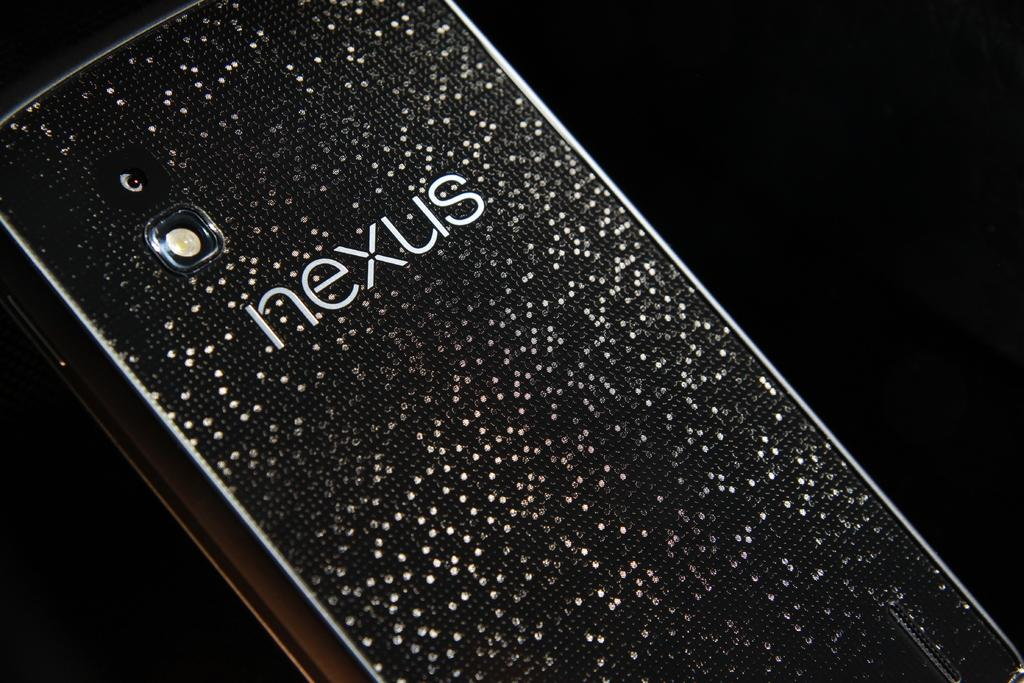<image>
Write a terse but informative summary of the picture. A Nexus smart phone with a black and white speckled phone case. 